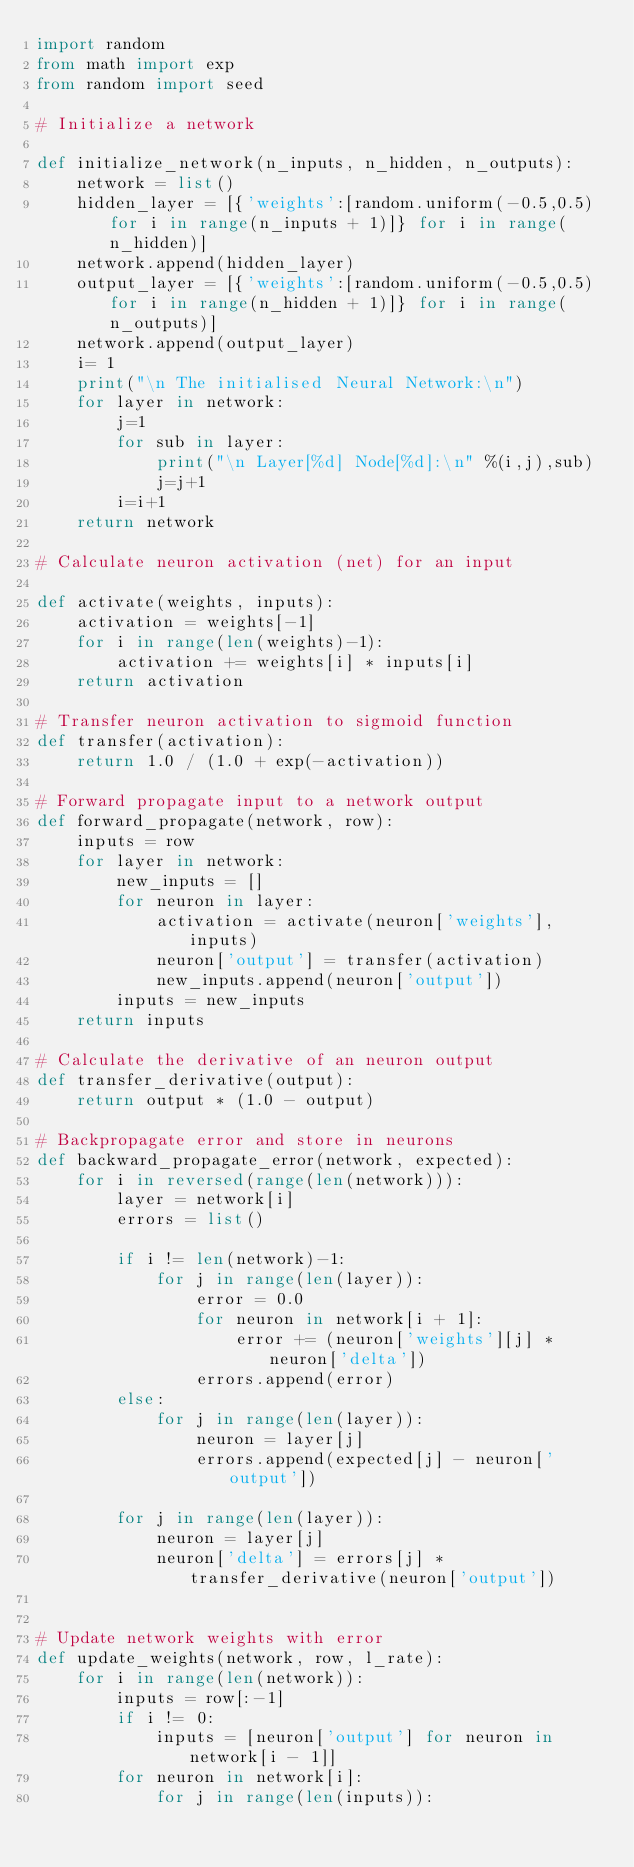<code> <loc_0><loc_0><loc_500><loc_500><_Python_>import random
from math import exp
from random import seed

# Initialize a network

def initialize_network(n_inputs, n_hidden, n_outputs):
    network = list()
    hidden_layer = [{'weights':[random.uniform(-0.5,0.5) for i in range(n_inputs + 1)]} for i in range(n_hidden)]
    network.append(hidden_layer)
    output_layer = [{'weights':[random.uniform(-0.5,0.5) for i in range(n_hidden + 1)]} for i in range(n_outputs)]
    network.append(output_layer)
    i= 1
    print("\n The initialised Neural Network:\n")
    for layer in network:
        j=1
        for sub in layer:
            print("\n Layer[%d] Node[%d]:\n" %(i,j),sub)
            j=j+1
        i=i+1
    return network

# Calculate neuron activation (net) for an input

def activate(weights, inputs):
    activation = weights[-1]
    for i in range(len(weights)-1):
        activation += weights[i] * inputs[i]
    return activation

# Transfer neuron activation to sigmoid function
def transfer(activation):
    return 1.0 / (1.0 + exp(-activation))

# Forward propagate input to a network output
def forward_propagate(network, row):
    inputs = row
    for layer in network:
        new_inputs = []
        for neuron in layer:
            activation = activate(neuron['weights'], inputs)
            neuron['output'] = transfer(activation)
            new_inputs.append(neuron['output'])
        inputs = new_inputs
    return inputs

# Calculate the derivative of an neuron output
def transfer_derivative(output):
    return output * (1.0 - output)

# Backpropagate error and store in neurons
def backward_propagate_error(network, expected):
    for i in reversed(range(len(network))):
        layer = network[i]
        errors = list()

        if i != len(network)-1:
            for j in range(len(layer)):
                error = 0.0
                for neuron in network[i + 1]:
                    error += (neuron['weights'][j] * neuron['delta'])
                errors.append(error)
        else:
            for j in range(len(layer)):
                neuron = layer[j]
                errors.append(expected[j] - neuron['output'])

        for j in range(len(layer)):
            neuron = layer[j]
            neuron['delta'] = errors[j] * transfer_derivative(neuron['output'])


# Update network weights with error
def update_weights(network, row, l_rate):
    for i in range(len(network)):
        inputs = row[:-1]
        if i != 0:
            inputs = [neuron['output'] for neuron in network[i - 1]]
        for neuron in network[i]:
            for j in range(len(inputs)):</code> 